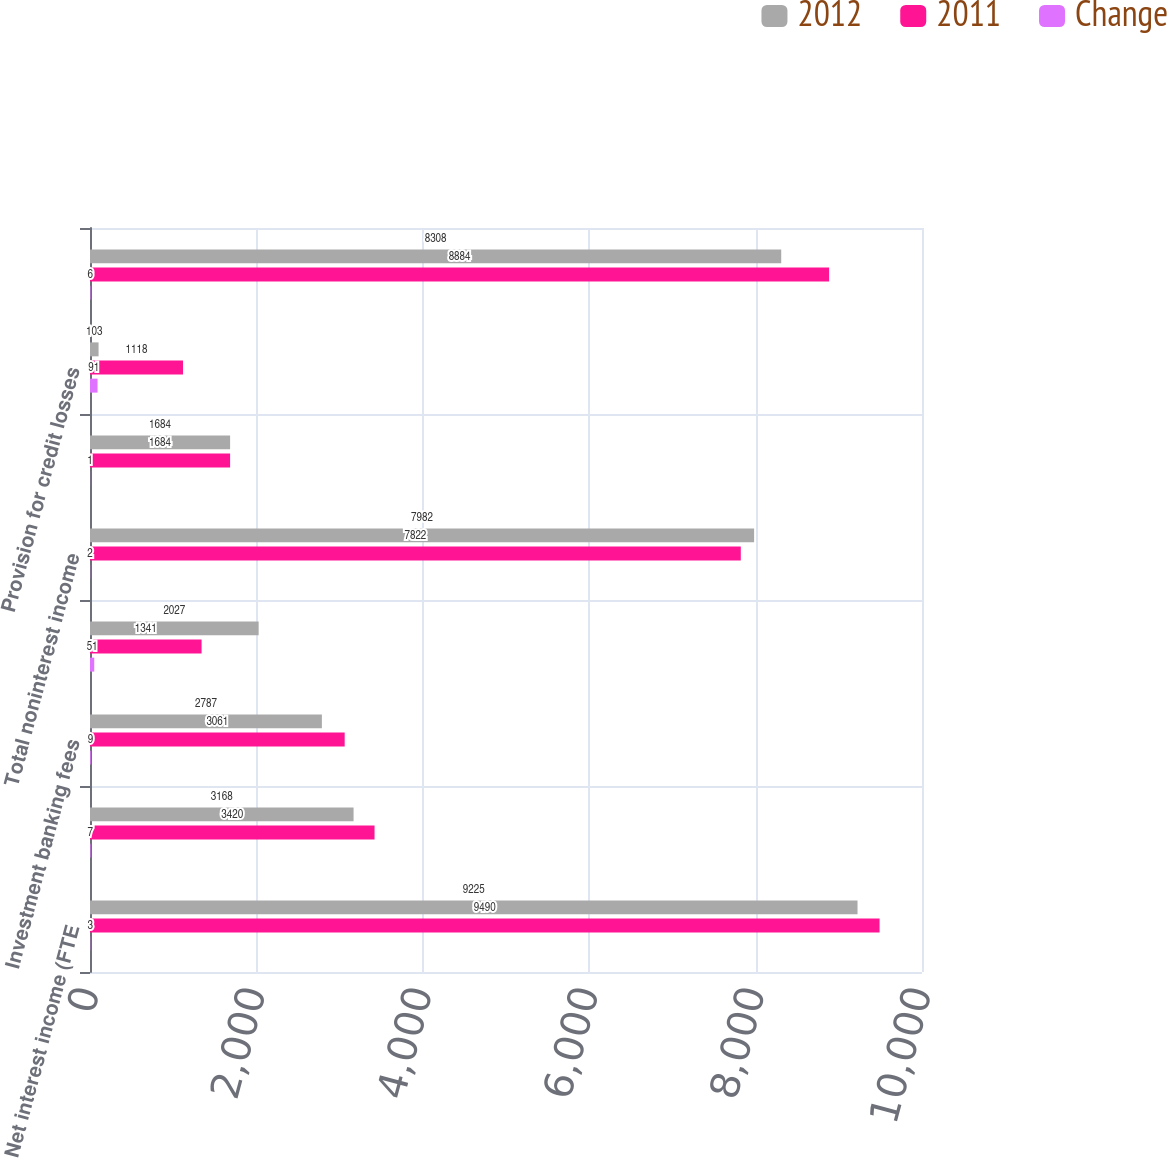Convert chart. <chart><loc_0><loc_0><loc_500><loc_500><stacked_bar_chart><ecel><fcel>Net interest income (FTE<fcel>Service charges<fcel>Investment banking fees<fcel>All other income<fcel>Total noninterest income<fcel>Total revenue net of interest<fcel>Provision for credit losses<fcel>Noninterest expense<nl><fcel>2012<fcel>9225<fcel>3168<fcel>2787<fcel>2027<fcel>7982<fcel>1684<fcel>103<fcel>8308<nl><fcel>2011<fcel>9490<fcel>3420<fcel>3061<fcel>1341<fcel>7822<fcel>1684<fcel>1118<fcel>8884<nl><fcel>Change<fcel>3<fcel>7<fcel>9<fcel>51<fcel>2<fcel>1<fcel>91<fcel>6<nl></chart> 